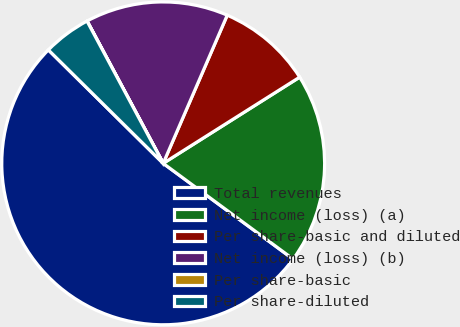Convert chart to OTSL. <chart><loc_0><loc_0><loc_500><loc_500><pie_chart><fcel>Total revenues<fcel>Net income (loss) (a)<fcel>Per share-basic and diluted<fcel>Net income (loss) (b)<fcel>Per share-basic<fcel>Per share-diluted<nl><fcel>52.3%<fcel>19.07%<fcel>9.54%<fcel>14.31%<fcel>0.01%<fcel>4.77%<nl></chart> 